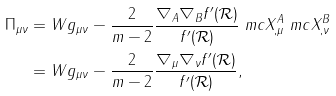Convert formula to latex. <formula><loc_0><loc_0><loc_500><loc_500>\Pi _ { \mu \nu } & = W g _ { \mu \nu } - \frac { 2 } { m - 2 } \frac { \nabla _ { A } \nabla _ { B } f ^ { \prime } ( \mathcal { R } ) } { f ^ { \prime } ( \mathcal { R } ) } \ m c { X } ^ { A } _ { , \mu } \ m c { X } ^ { B } _ { , \nu } \\ & = W g _ { \mu \nu } - \frac { 2 } { m - 2 } \frac { \nabla _ { \mu } \nabla _ { \nu } f ^ { \prime } ( \mathcal { R } ) } { f ^ { \prime } ( \mathcal { R } ) } ,</formula> 